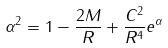Convert formula to latex. <formula><loc_0><loc_0><loc_500><loc_500>\alpha ^ { 2 } = 1 - \frac { 2 M } { R } + \frac { C ^ { 2 } } { R ^ { 4 } } e ^ { \alpha }</formula> 